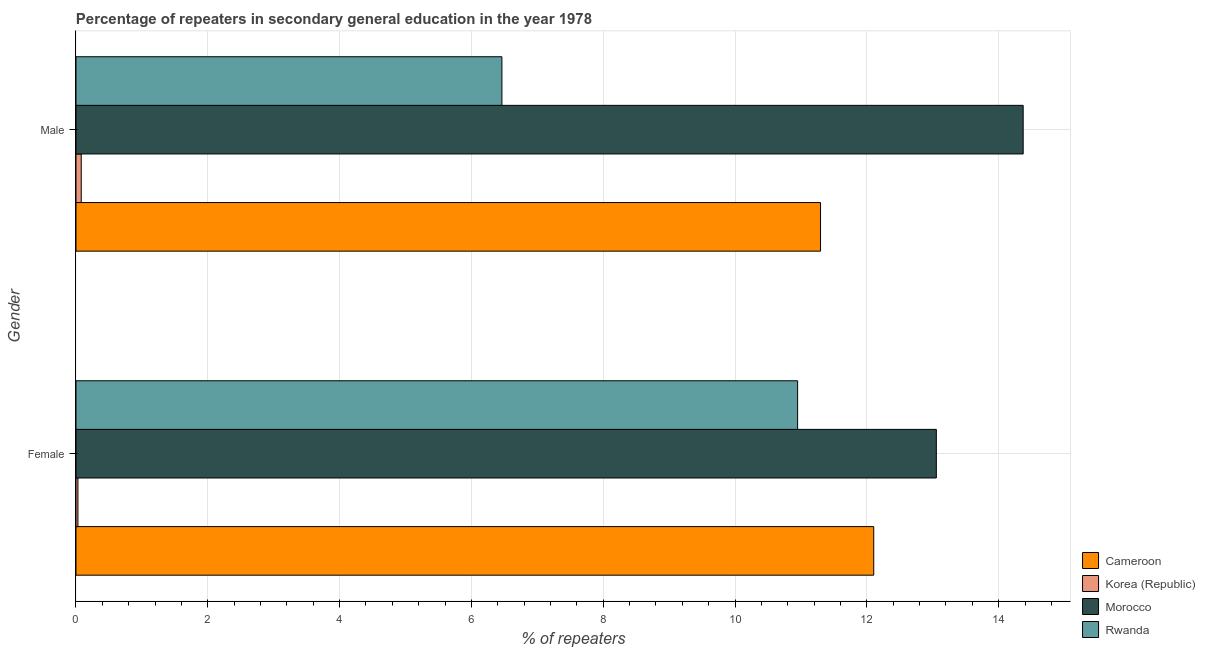How many groups of bars are there?
Keep it short and to the point. 2. How many bars are there on the 2nd tick from the bottom?
Your answer should be very brief. 4. What is the label of the 1st group of bars from the top?
Your answer should be compact. Male. What is the percentage of female repeaters in Korea (Republic)?
Ensure brevity in your answer.  0.03. Across all countries, what is the maximum percentage of female repeaters?
Provide a succinct answer. 13.05. Across all countries, what is the minimum percentage of male repeaters?
Give a very brief answer. 0.08. In which country was the percentage of female repeaters maximum?
Your answer should be very brief. Morocco. In which country was the percentage of male repeaters minimum?
Keep it short and to the point. Korea (Republic). What is the total percentage of male repeaters in the graph?
Keep it short and to the point. 32.21. What is the difference between the percentage of female repeaters in Rwanda and that in Cameroon?
Make the answer very short. -1.15. What is the difference between the percentage of female repeaters in Rwanda and the percentage of male repeaters in Morocco?
Provide a succinct answer. -3.42. What is the average percentage of female repeaters per country?
Your answer should be very brief. 9.03. What is the difference between the percentage of male repeaters and percentage of female repeaters in Korea (Republic)?
Offer a terse response. 0.05. What is the ratio of the percentage of female repeaters in Morocco to that in Rwanda?
Provide a succinct answer. 1.19. Is the percentage of male repeaters in Korea (Republic) less than that in Cameroon?
Give a very brief answer. Yes. In how many countries, is the percentage of female repeaters greater than the average percentage of female repeaters taken over all countries?
Give a very brief answer. 3. What does the 1st bar from the top in Male represents?
Keep it short and to the point. Rwanda. What does the 1st bar from the bottom in Female represents?
Offer a terse response. Cameroon. Are all the bars in the graph horizontal?
Provide a succinct answer. Yes. How many countries are there in the graph?
Provide a succinct answer. 4. What is the difference between two consecutive major ticks on the X-axis?
Make the answer very short. 2. Does the graph contain any zero values?
Offer a terse response. No. What is the title of the graph?
Ensure brevity in your answer.  Percentage of repeaters in secondary general education in the year 1978. Does "El Salvador" appear as one of the legend labels in the graph?
Offer a terse response. No. What is the label or title of the X-axis?
Keep it short and to the point. % of repeaters. What is the % of repeaters in Cameroon in Female?
Offer a terse response. 12.1. What is the % of repeaters in Korea (Republic) in Female?
Ensure brevity in your answer.  0.03. What is the % of repeaters in Morocco in Female?
Give a very brief answer. 13.05. What is the % of repeaters in Rwanda in Female?
Provide a succinct answer. 10.95. What is the % of repeaters in Cameroon in Male?
Ensure brevity in your answer.  11.3. What is the % of repeaters in Korea (Republic) in Male?
Keep it short and to the point. 0.08. What is the % of repeaters of Morocco in Male?
Provide a short and direct response. 14.37. What is the % of repeaters of Rwanda in Male?
Keep it short and to the point. 6.46. Across all Gender, what is the maximum % of repeaters in Cameroon?
Keep it short and to the point. 12.1. Across all Gender, what is the maximum % of repeaters of Korea (Republic)?
Ensure brevity in your answer.  0.08. Across all Gender, what is the maximum % of repeaters in Morocco?
Offer a terse response. 14.37. Across all Gender, what is the maximum % of repeaters of Rwanda?
Your answer should be very brief. 10.95. Across all Gender, what is the minimum % of repeaters in Cameroon?
Ensure brevity in your answer.  11.3. Across all Gender, what is the minimum % of repeaters of Korea (Republic)?
Offer a very short reply. 0.03. Across all Gender, what is the minimum % of repeaters of Morocco?
Offer a very short reply. 13.05. Across all Gender, what is the minimum % of repeaters of Rwanda?
Keep it short and to the point. 6.46. What is the total % of repeaters of Cameroon in the graph?
Make the answer very short. 23.4. What is the total % of repeaters of Korea (Republic) in the graph?
Your answer should be very brief. 0.11. What is the total % of repeaters in Morocco in the graph?
Your answer should be compact. 27.43. What is the total % of repeaters of Rwanda in the graph?
Your response must be concise. 17.41. What is the difference between the % of repeaters of Cameroon in Female and that in Male?
Offer a very short reply. 0.81. What is the difference between the % of repeaters in Korea (Republic) in Female and that in Male?
Your answer should be very brief. -0.05. What is the difference between the % of repeaters of Morocco in Female and that in Male?
Offer a very short reply. -1.32. What is the difference between the % of repeaters of Rwanda in Female and that in Male?
Offer a terse response. 4.49. What is the difference between the % of repeaters of Cameroon in Female and the % of repeaters of Korea (Republic) in Male?
Offer a terse response. 12.02. What is the difference between the % of repeaters in Cameroon in Female and the % of repeaters in Morocco in Male?
Provide a succinct answer. -2.27. What is the difference between the % of repeaters of Cameroon in Female and the % of repeaters of Rwanda in Male?
Offer a terse response. 5.64. What is the difference between the % of repeaters in Korea (Republic) in Female and the % of repeaters in Morocco in Male?
Your response must be concise. -14.34. What is the difference between the % of repeaters in Korea (Republic) in Female and the % of repeaters in Rwanda in Male?
Your answer should be very brief. -6.43. What is the difference between the % of repeaters in Morocco in Female and the % of repeaters in Rwanda in Male?
Keep it short and to the point. 6.59. What is the average % of repeaters in Cameroon per Gender?
Give a very brief answer. 11.7. What is the average % of repeaters in Korea (Republic) per Gender?
Provide a short and direct response. 0.05. What is the average % of repeaters of Morocco per Gender?
Your answer should be very brief. 13.71. What is the average % of repeaters in Rwanda per Gender?
Provide a short and direct response. 8.71. What is the difference between the % of repeaters in Cameroon and % of repeaters in Korea (Republic) in Female?
Keep it short and to the point. 12.08. What is the difference between the % of repeaters of Cameroon and % of repeaters of Morocco in Female?
Ensure brevity in your answer.  -0.95. What is the difference between the % of repeaters in Cameroon and % of repeaters in Rwanda in Female?
Provide a succinct answer. 1.15. What is the difference between the % of repeaters of Korea (Republic) and % of repeaters of Morocco in Female?
Your response must be concise. -13.02. What is the difference between the % of repeaters of Korea (Republic) and % of repeaters of Rwanda in Female?
Make the answer very short. -10.92. What is the difference between the % of repeaters in Morocco and % of repeaters in Rwanda in Female?
Your answer should be very brief. 2.1. What is the difference between the % of repeaters in Cameroon and % of repeaters in Korea (Republic) in Male?
Ensure brevity in your answer.  11.22. What is the difference between the % of repeaters of Cameroon and % of repeaters of Morocco in Male?
Your answer should be compact. -3.07. What is the difference between the % of repeaters of Cameroon and % of repeaters of Rwanda in Male?
Your response must be concise. 4.83. What is the difference between the % of repeaters in Korea (Republic) and % of repeaters in Morocco in Male?
Ensure brevity in your answer.  -14.29. What is the difference between the % of repeaters in Korea (Republic) and % of repeaters in Rwanda in Male?
Offer a terse response. -6.38. What is the difference between the % of repeaters of Morocco and % of repeaters of Rwanda in Male?
Offer a terse response. 7.91. What is the ratio of the % of repeaters of Cameroon in Female to that in Male?
Provide a succinct answer. 1.07. What is the ratio of the % of repeaters of Korea (Republic) in Female to that in Male?
Provide a short and direct response. 0.37. What is the ratio of the % of repeaters of Morocco in Female to that in Male?
Make the answer very short. 0.91. What is the ratio of the % of repeaters in Rwanda in Female to that in Male?
Your answer should be very brief. 1.69. What is the difference between the highest and the second highest % of repeaters of Cameroon?
Your response must be concise. 0.81. What is the difference between the highest and the second highest % of repeaters of Korea (Republic)?
Provide a succinct answer. 0.05. What is the difference between the highest and the second highest % of repeaters of Morocco?
Make the answer very short. 1.32. What is the difference between the highest and the second highest % of repeaters of Rwanda?
Provide a succinct answer. 4.49. What is the difference between the highest and the lowest % of repeaters of Cameroon?
Offer a very short reply. 0.81. What is the difference between the highest and the lowest % of repeaters in Korea (Republic)?
Give a very brief answer. 0.05. What is the difference between the highest and the lowest % of repeaters in Morocco?
Offer a very short reply. 1.32. What is the difference between the highest and the lowest % of repeaters in Rwanda?
Your response must be concise. 4.49. 